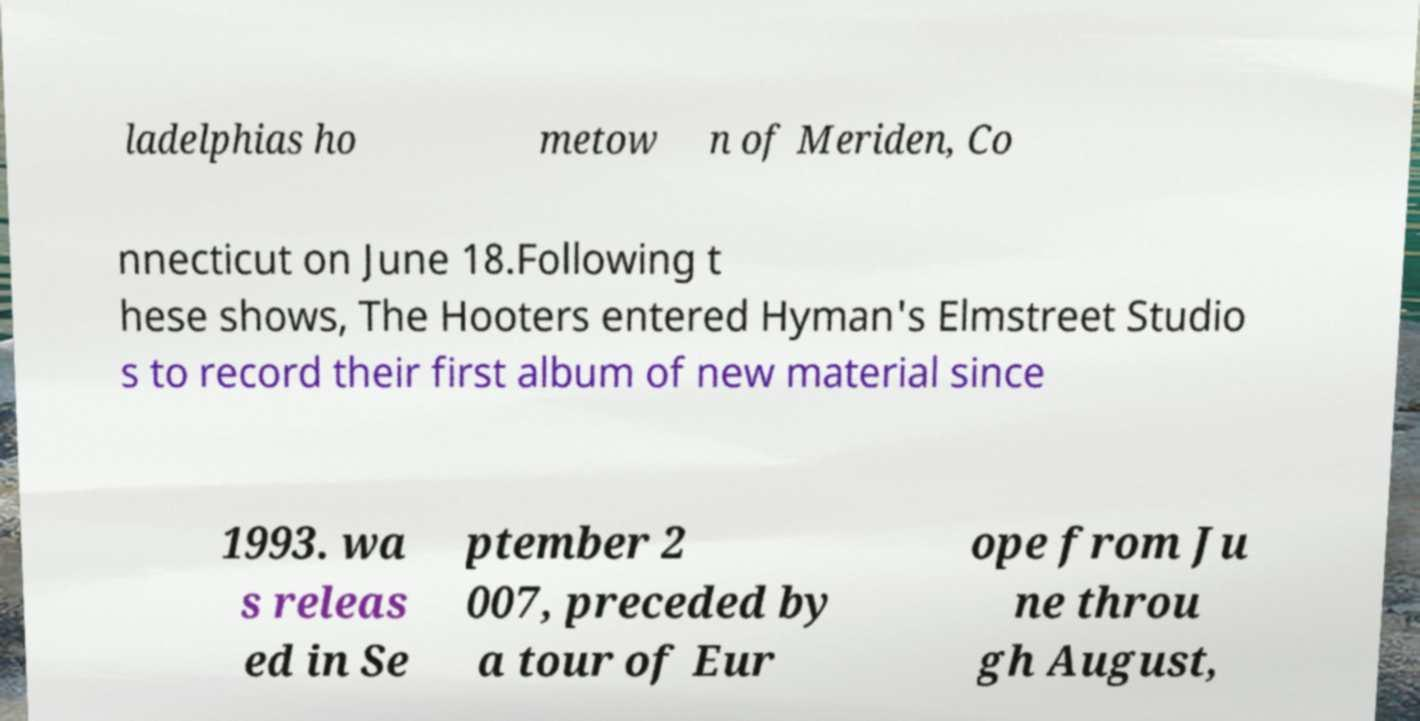What messages or text are displayed in this image? I need them in a readable, typed format. ladelphias ho metow n of Meriden, Co nnecticut on June 18.Following t hese shows, The Hooters entered Hyman's Elmstreet Studio s to record their first album of new material since 1993. wa s releas ed in Se ptember 2 007, preceded by a tour of Eur ope from Ju ne throu gh August, 